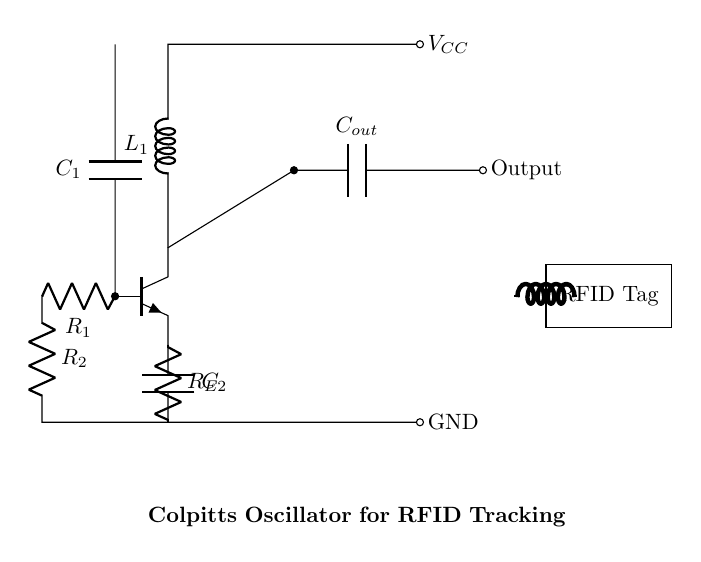What is the type of transistor used in this circuit? The circuit uses an NPN transistor, indicated by the npn label on the transistor symbol in the diagram.
Answer: NPN What are the capacitance values of the capacitors in the circuit? The circuit diagram labels two capacitors, C1 and C2. However, the specific capacitance values are not shown; it's implied that they are key components in the Colpitts oscillator configuration.
Answer: Not specified How many resistors are present in the circuit? The circuit diagram shows three resistors labeled R1, R2, and RE, indicating the total number of resistors.
Answer: Three What is the purpose of the inductor in this circuit? In the Colpitts oscillator, the inductor L1 is crucial for establishing the resonant frequency, working alongside the capacitors to generate oscillations.
Answer: Resonance What is the function of the output capacitor Cout? The output capacitor Cout is used in the circuit to block DC voltage while allowing AC signals to pass through, which is essential for signal processing in RFID applications.
Answer: Signal coupling What type of circuit is depicted in the diagram? The circuit is specifically a Colpitts oscillator, distinguished by its feedback network that uses capacitors and an inductor to sustain oscillations.
Answer: Colpitts oscillator How does the Colpitts oscillator achieve oscillation in this circuit? The oscillation is achieved through the feedback mechanism provided by the combination of the inductor L1 and the capacitors C1 and C2, creating a resonant circuit that allows for sustained oscillations at a particular frequency determined by their values.
Answer: Feedback mechanism 